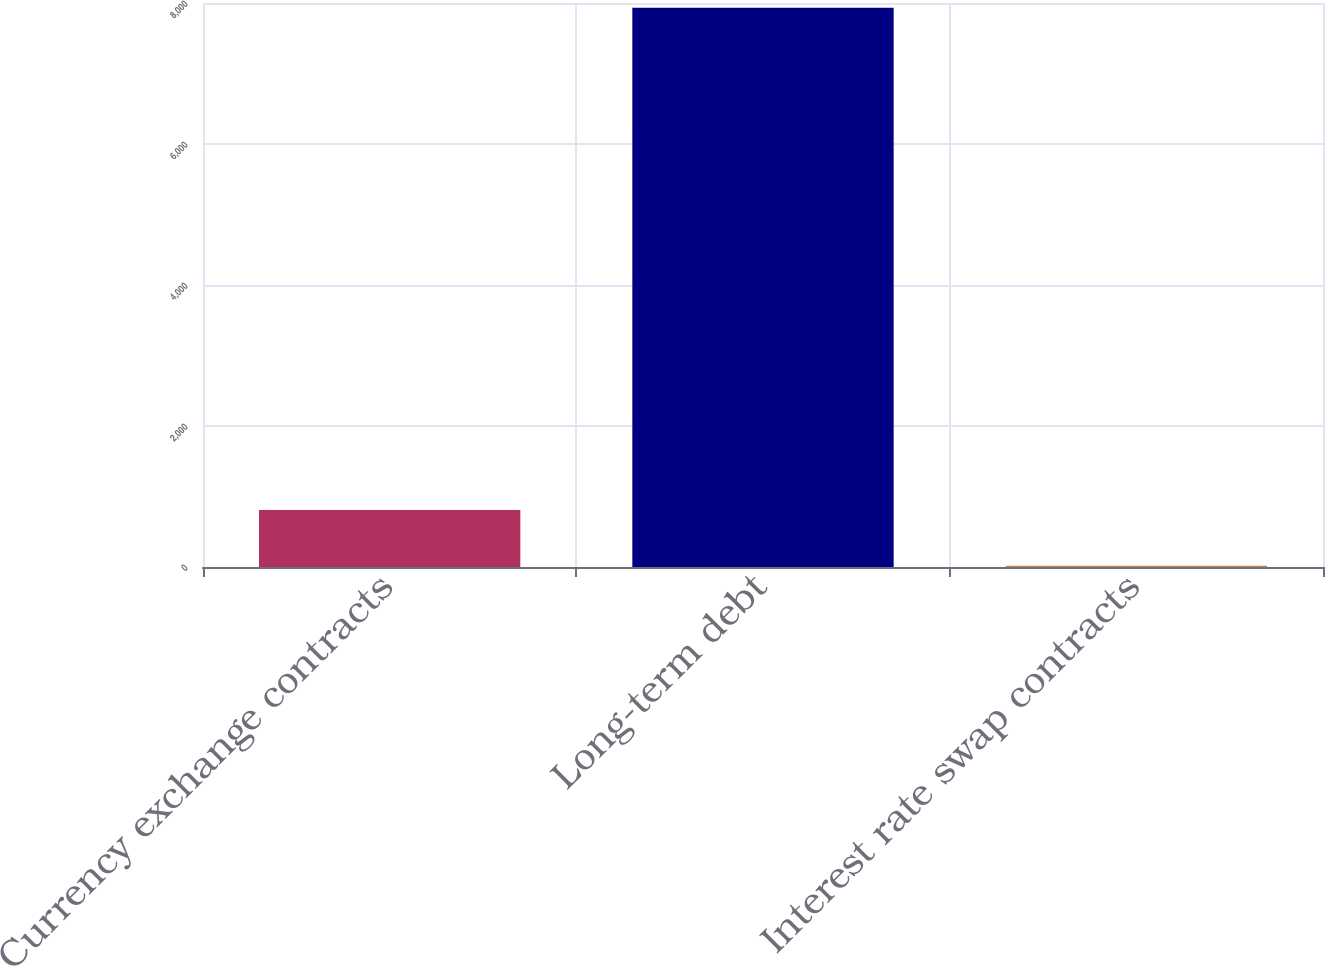Convert chart. <chart><loc_0><loc_0><loc_500><loc_500><bar_chart><fcel>Currency exchange contracts<fcel>Long-term debt<fcel>Interest rate swap contracts<nl><fcel>808.6<fcel>7933<fcel>17<nl></chart> 